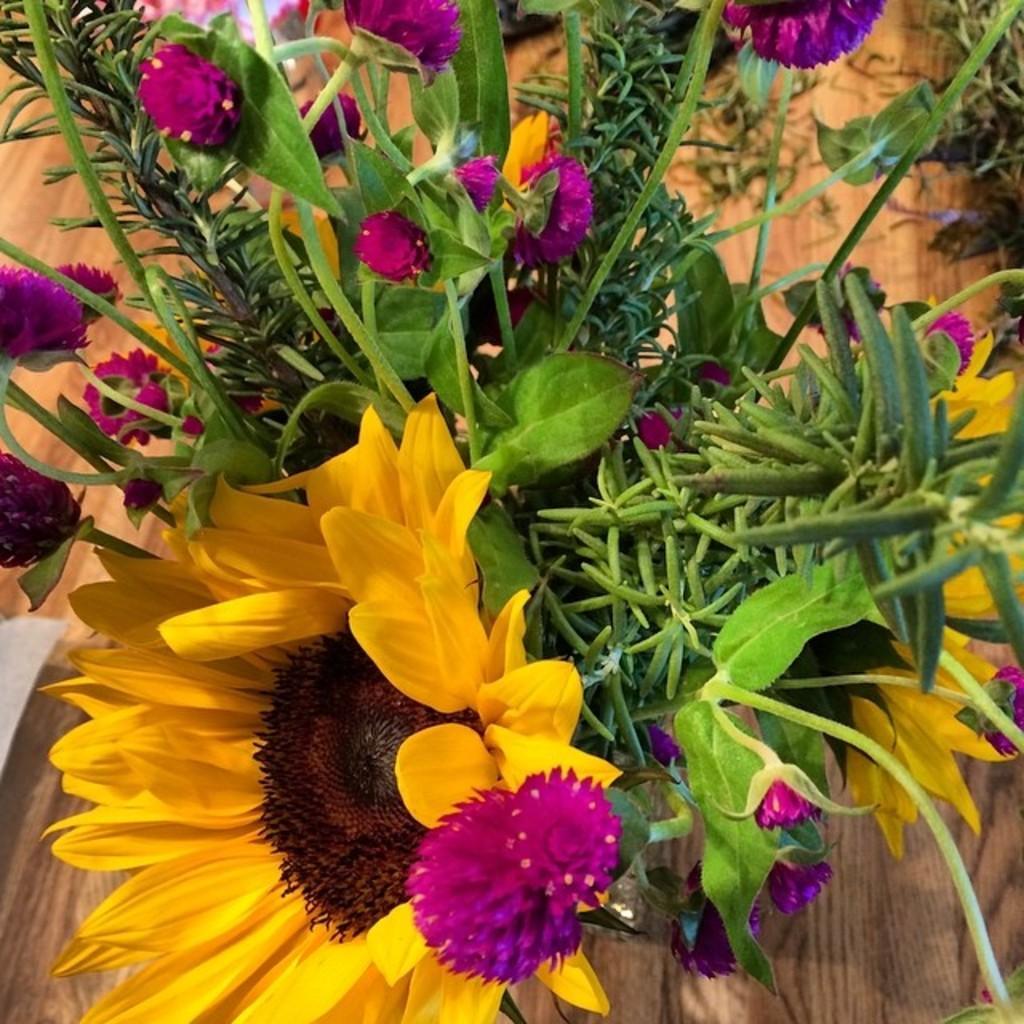Can you describe this image briefly? In the image there is a plant with sunflower and pink color flowers to it on a wooden floor. 